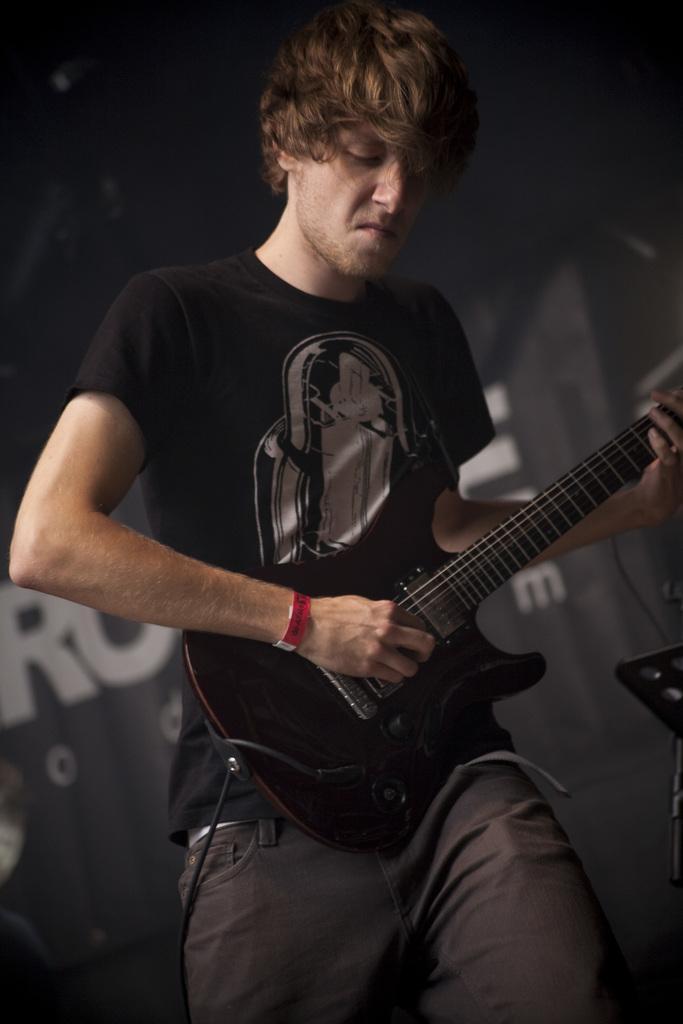Could you give a brief overview of what you see in this image? This person standing and playing guitar. On the background we can see banner. 